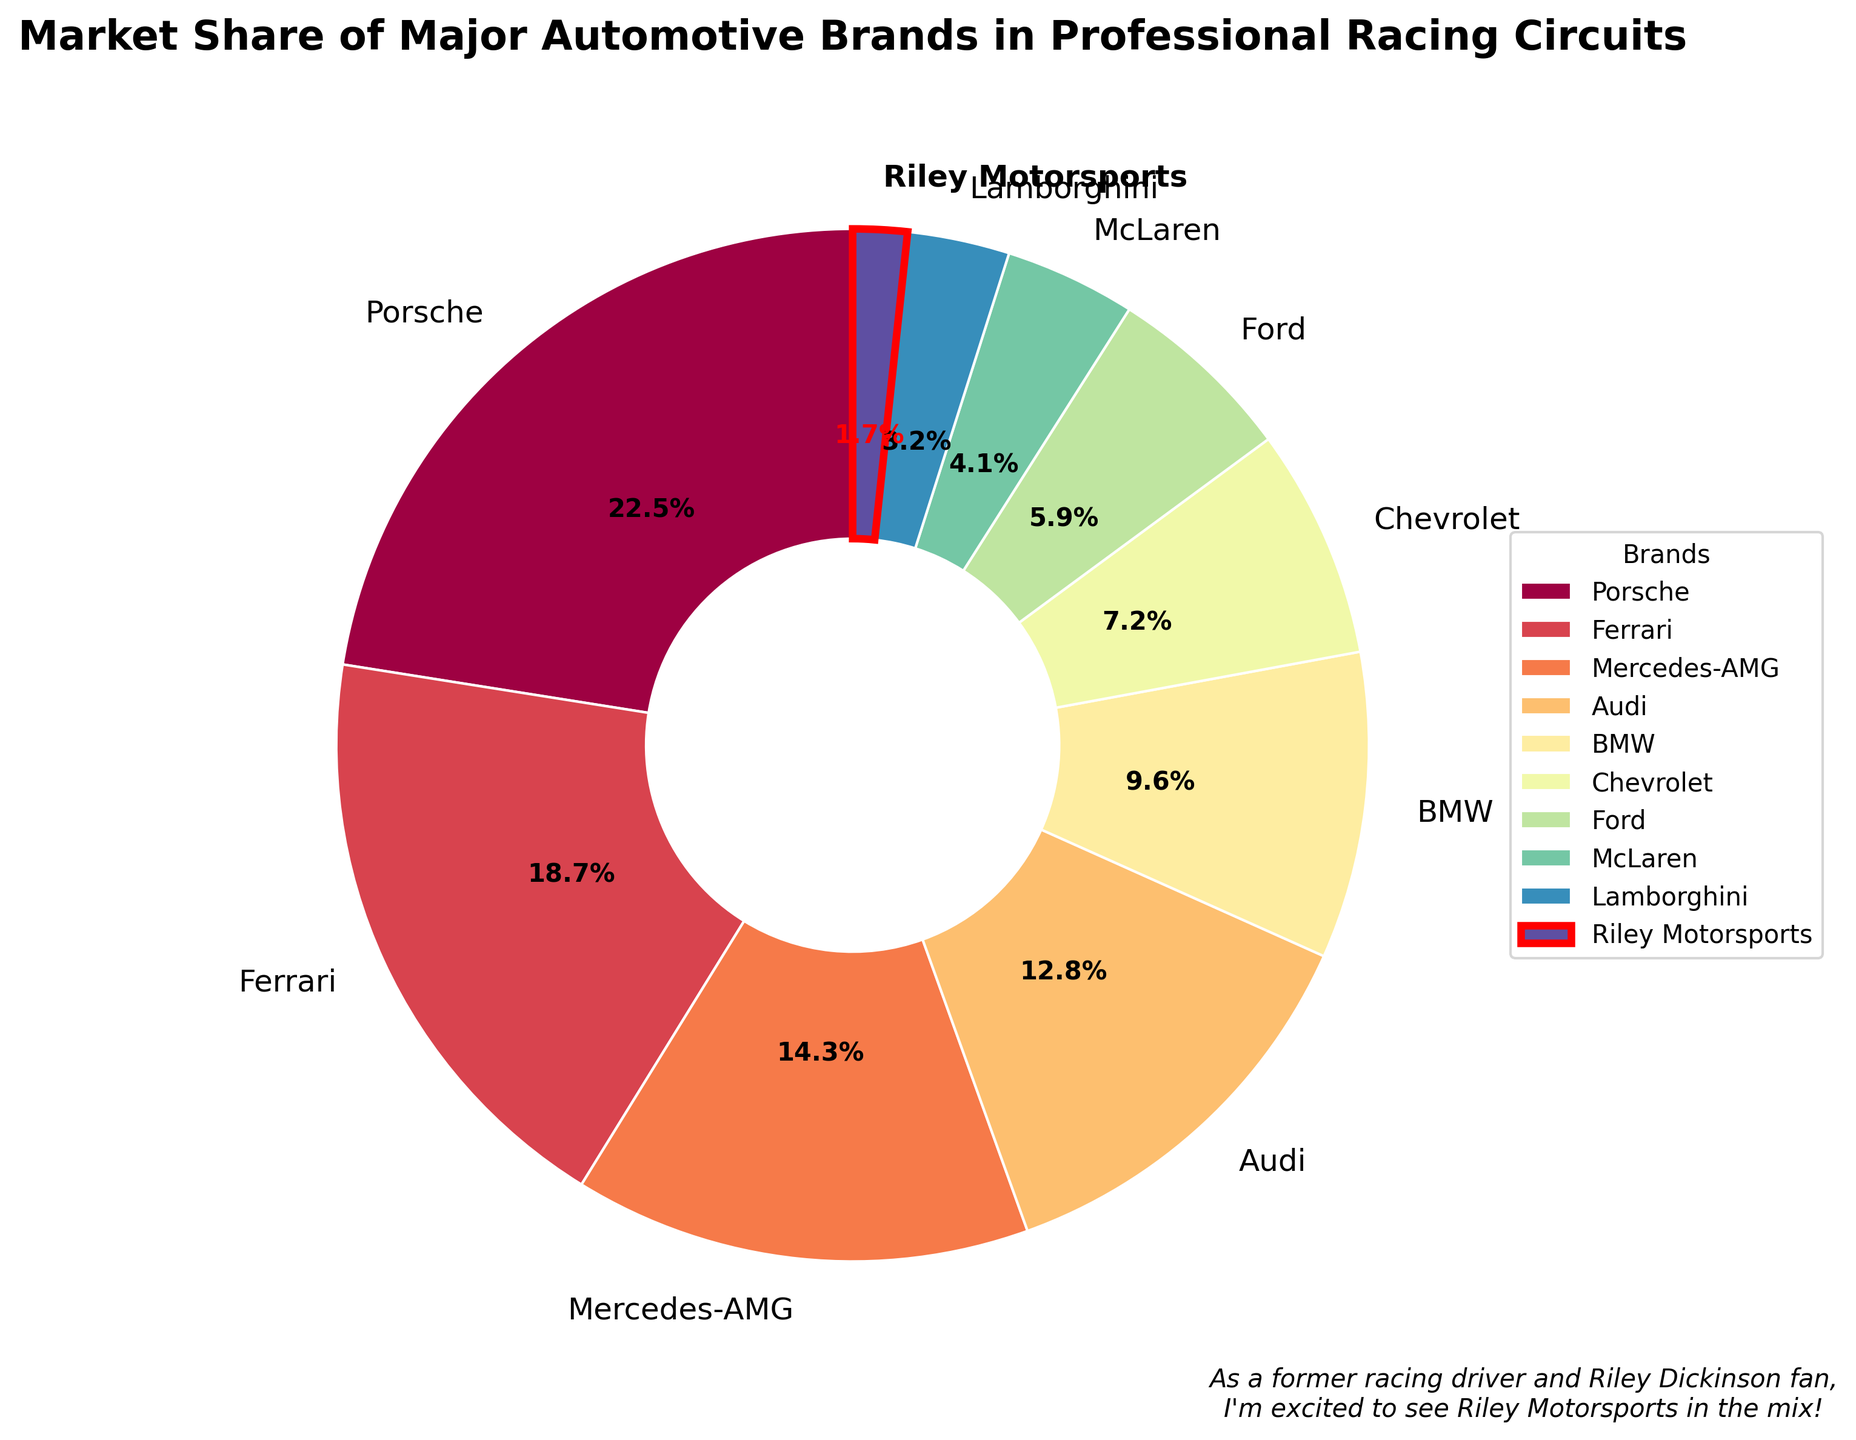Which brand has the highest market share? By observing the pie chart, the largest segment (slice) belongs to Porsche.
Answer: Porsche How does Mercedes-AMG's market share compare to BMW's? From the chart, Mercedes-AMG has a market share of 14.3%, while BMW has a market share of 9.6%. Comparing these values, Mercedes-AMG's market share is higher than BMW's.
Answer: Mercedes-AMG's market share is higher What is the combined market share of Ferrari and Audi? Ferrari's market share is 18.7%, and Audi's market share is 12.8%. Adding these together gives 18.7% + 12.8% = 31.5%.
Answer: 31.5% Which brand is highlighted distinctively in the pie chart? Riley Motorsports is outlined in red and has bold text, making it stand out in the chart.
Answer: Riley Motorsports What is the difference in market share between Ford and Chevrolet? The market share for Chevrolet is 7.2%, while for Ford, it is 5.9%. The difference is 7.2% - 5.9% = 1.3%.
Answer: 1.3% What is the ratio of Porsche's market share to Lamborghini's market share? Porsche's market share is 22.5%, and Lamborghini's market share is 3.2%. The ratio is 22.5 / 3.2 = 7.03125.
Answer: Approximately 7:1 How many brands have a market share greater than 10%? From the pie chart, Porsche, Ferrari, Mercedes-AMG, and Audi each have a market share greater than 10%.
Answer: Four brands What percentage of the market do Chevrolet and Ford share together? Chevrolet has a market share of 7.2% and Ford has 5.9%. Their combined market share is 7.2% + 5.9% = 13.1%.
Answer: 13.1% Which brand has the smallest market share and what is its value? Among the segments in the pie chart, Riley Motorsports has the smallest market share of 1.7%.
Answer: Riley Motorsports, 1.7% How much more market share does McLaren need to match Audi? McLaren's market share is 4.1%, and Audi's market share is 12.8%. The difference is 12.8% - 4.1% = 8.7%.
Answer: 8.7% 